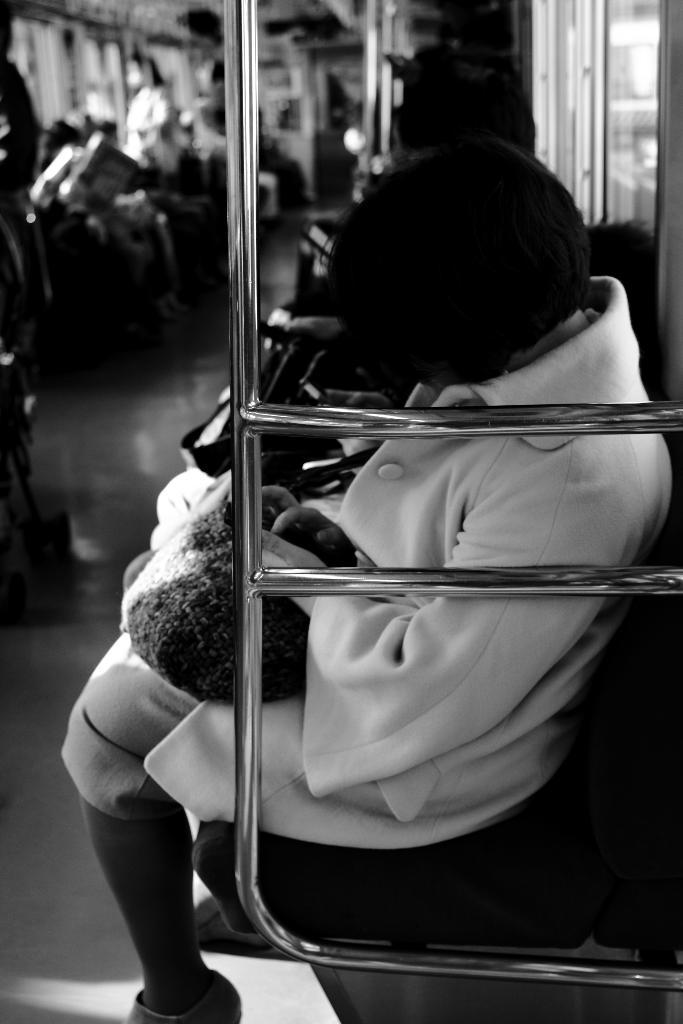Who or what is present in the image? There are people in the image. What are the people wearing? The people are wearing clothes. What are the people doing in the image? The people are sitting on seats. What type of setting is depicted in the image? The image depicts the internal structure of a vehicle. What type of bird can be seen flying on a slope in the image? There is no bird or slope present in the image; it depicts the internal structure of a vehicle with people sitting on seats. 